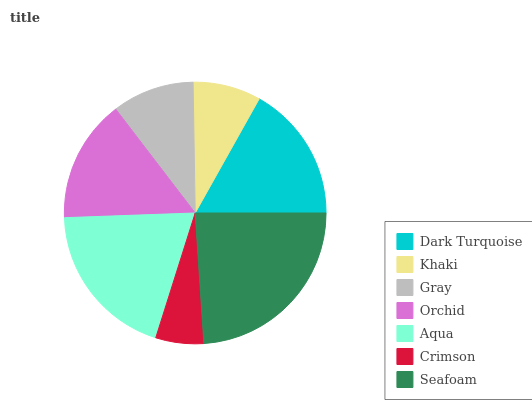Is Crimson the minimum?
Answer yes or no. Yes. Is Seafoam the maximum?
Answer yes or no. Yes. Is Khaki the minimum?
Answer yes or no. No. Is Khaki the maximum?
Answer yes or no. No. Is Dark Turquoise greater than Khaki?
Answer yes or no. Yes. Is Khaki less than Dark Turquoise?
Answer yes or no. Yes. Is Khaki greater than Dark Turquoise?
Answer yes or no. No. Is Dark Turquoise less than Khaki?
Answer yes or no. No. Is Orchid the high median?
Answer yes or no. Yes. Is Orchid the low median?
Answer yes or no. Yes. Is Crimson the high median?
Answer yes or no. No. Is Gray the low median?
Answer yes or no. No. 